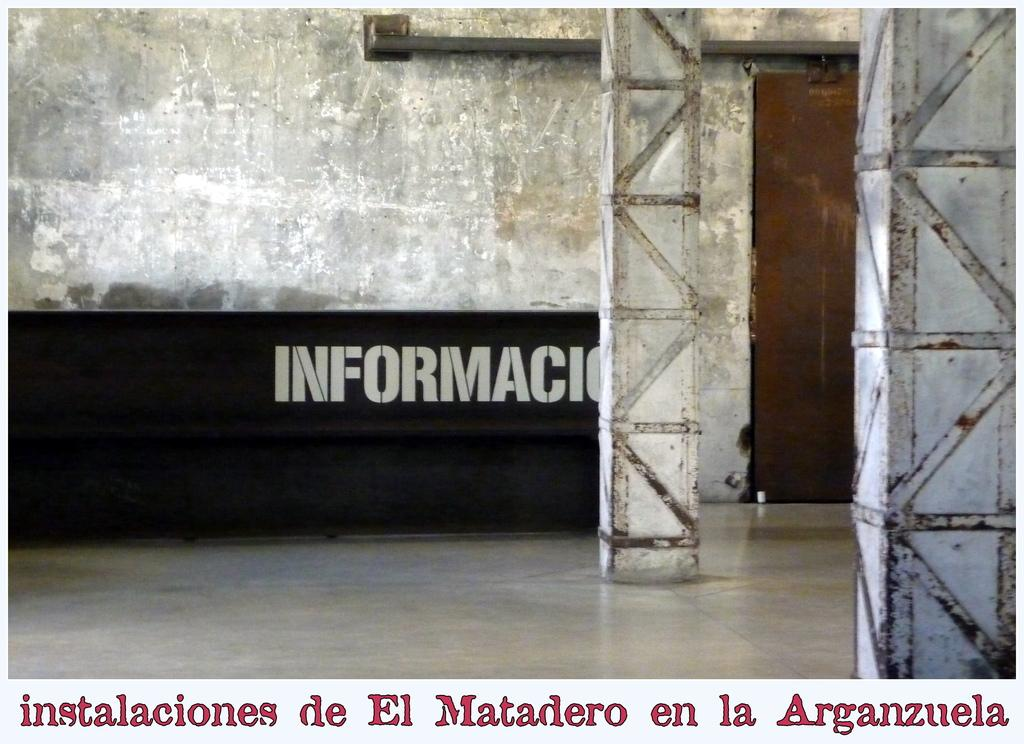What is written on in the image? There is a wall with text in the image. What architectural features can be seen in the image? There are pillars in the image. Is there a way to enter or exit the area depicted in the image? Yes, there is a door in the image. What additional text is present in the image? There is text at the bottom of the image. How many pets are visible in the field in the image? There are no pets or fields present in the image. Can you describe the tiger's behavior in the image? There is no tiger present in the image. 